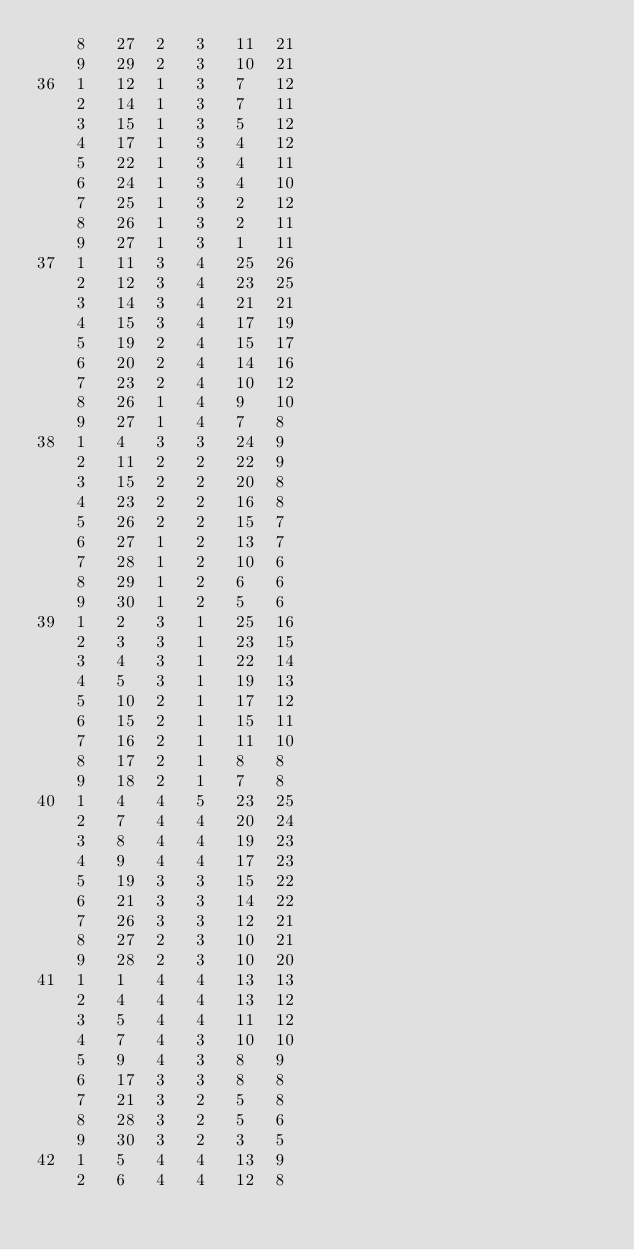<code> <loc_0><loc_0><loc_500><loc_500><_ObjectiveC_>	8	27	2	3	11	21	
	9	29	2	3	10	21	
36	1	12	1	3	7	12	
	2	14	1	3	7	11	
	3	15	1	3	5	12	
	4	17	1	3	4	12	
	5	22	1	3	4	11	
	6	24	1	3	4	10	
	7	25	1	3	2	12	
	8	26	1	3	2	11	
	9	27	1	3	1	11	
37	1	11	3	4	25	26	
	2	12	3	4	23	25	
	3	14	3	4	21	21	
	4	15	3	4	17	19	
	5	19	2	4	15	17	
	6	20	2	4	14	16	
	7	23	2	4	10	12	
	8	26	1	4	9	10	
	9	27	1	4	7	8	
38	1	4	3	3	24	9	
	2	11	2	2	22	9	
	3	15	2	2	20	8	
	4	23	2	2	16	8	
	5	26	2	2	15	7	
	6	27	1	2	13	7	
	7	28	1	2	10	6	
	8	29	1	2	6	6	
	9	30	1	2	5	6	
39	1	2	3	1	25	16	
	2	3	3	1	23	15	
	3	4	3	1	22	14	
	4	5	3	1	19	13	
	5	10	2	1	17	12	
	6	15	2	1	15	11	
	7	16	2	1	11	10	
	8	17	2	1	8	8	
	9	18	2	1	7	8	
40	1	4	4	5	23	25	
	2	7	4	4	20	24	
	3	8	4	4	19	23	
	4	9	4	4	17	23	
	5	19	3	3	15	22	
	6	21	3	3	14	22	
	7	26	3	3	12	21	
	8	27	2	3	10	21	
	9	28	2	3	10	20	
41	1	1	4	4	13	13	
	2	4	4	4	13	12	
	3	5	4	4	11	12	
	4	7	4	3	10	10	
	5	9	4	3	8	9	
	6	17	3	3	8	8	
	7	21	3	2	5	8	
	8	28	3	2	5	6	
	9	30	3	2	3	5	
42	1	5	4	4	13	9	
	2	6	4	4	12	8	</code> 